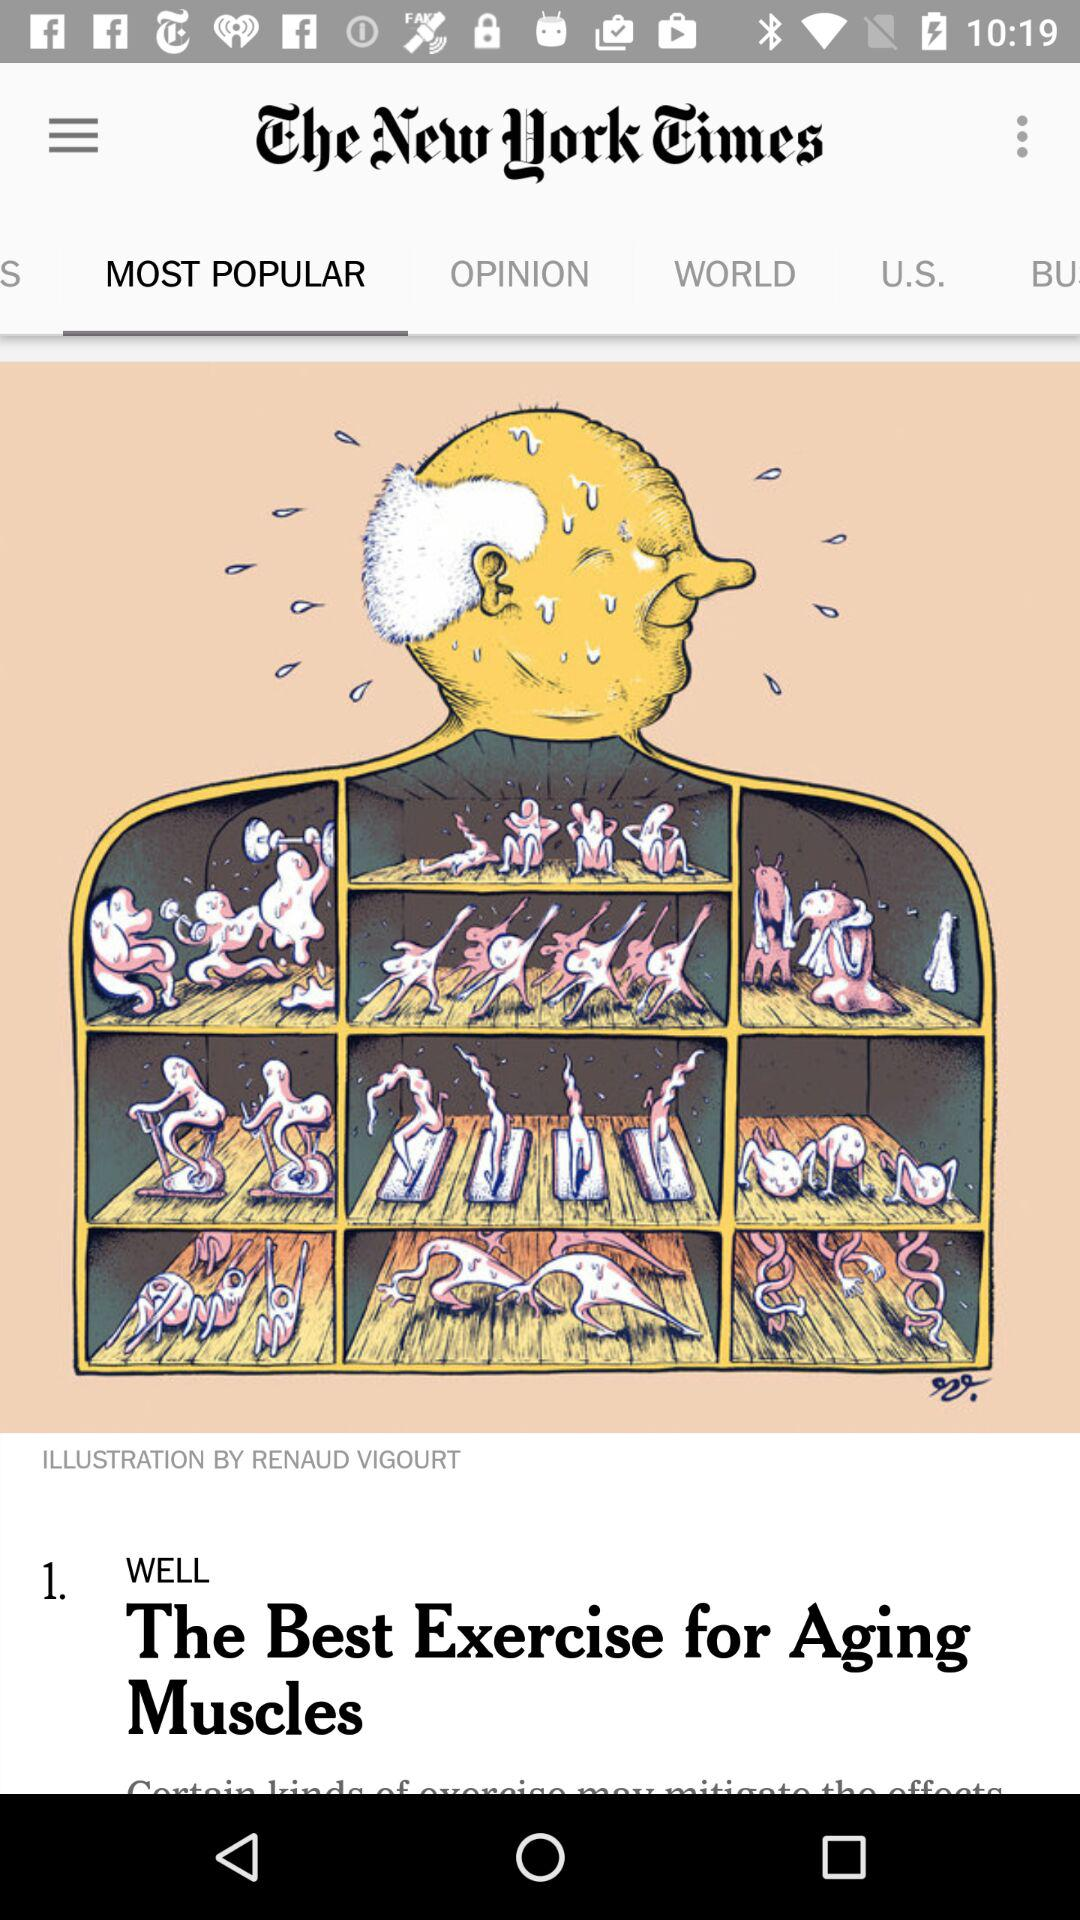What's the illustrator name? The illustrator name is Renaud Vigourt. 